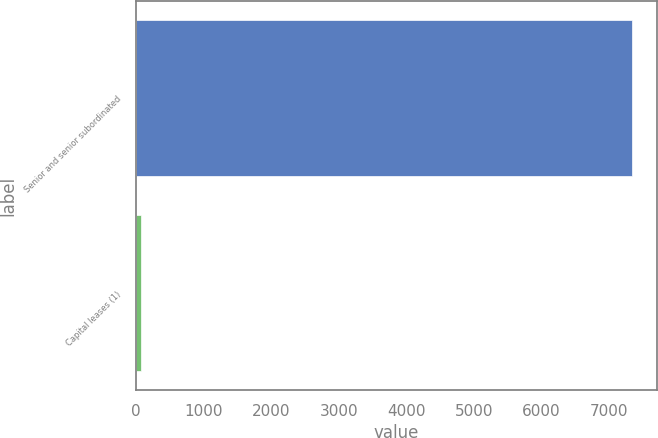Convert chart to OTSL. <chart><loc_0><loc_0><loc_500><loc_500><bar_chart><fcel>Senior and senior subordinated<fcel>Capital leases (1)<nl><fcel>7340<fcel>65<nl></chart> 